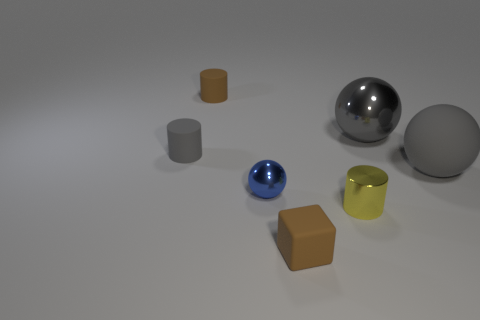What color is the small cylinder that is in front of the big gray shiny ball and behind the blue sphere?
Provide a short and direct response. Gray. How many big matte cylinders are there?
Give a very brief answer. 0. Does the brown cube have the same size as the brown rubber cylinder?
Provide a short and direct response. Yes. Are there any small matte cylinders of the same color as the matte sphere?
Make the answer very short. Yes. There is a blue shiny object left of the brown block; does it have the same shape as the small yellow metal thing?
Offer a terse response. No. What number of brown matte things have the same size as the blue sphere?
Your answer should be compact. 2. There is a gray rubber object that is right of the brown matte cylinder; what number of gray shiny objects are right of it?
Keep it short and to the point. 0. Are the big gray thing behind the gray cylinder and the small yellow cylinder made of the same material?
Provide a succinct answer. Yes. Does the big sphere on the left side of the large gray matte sphere have the same material as the yellow thing that is on the left side of the big metallic object?
Your response must be concise. Yes. Are there more large gray matte spheres that are behind the tiny gray rubber thing than brown rubber things?
Offer a terse response. No. 